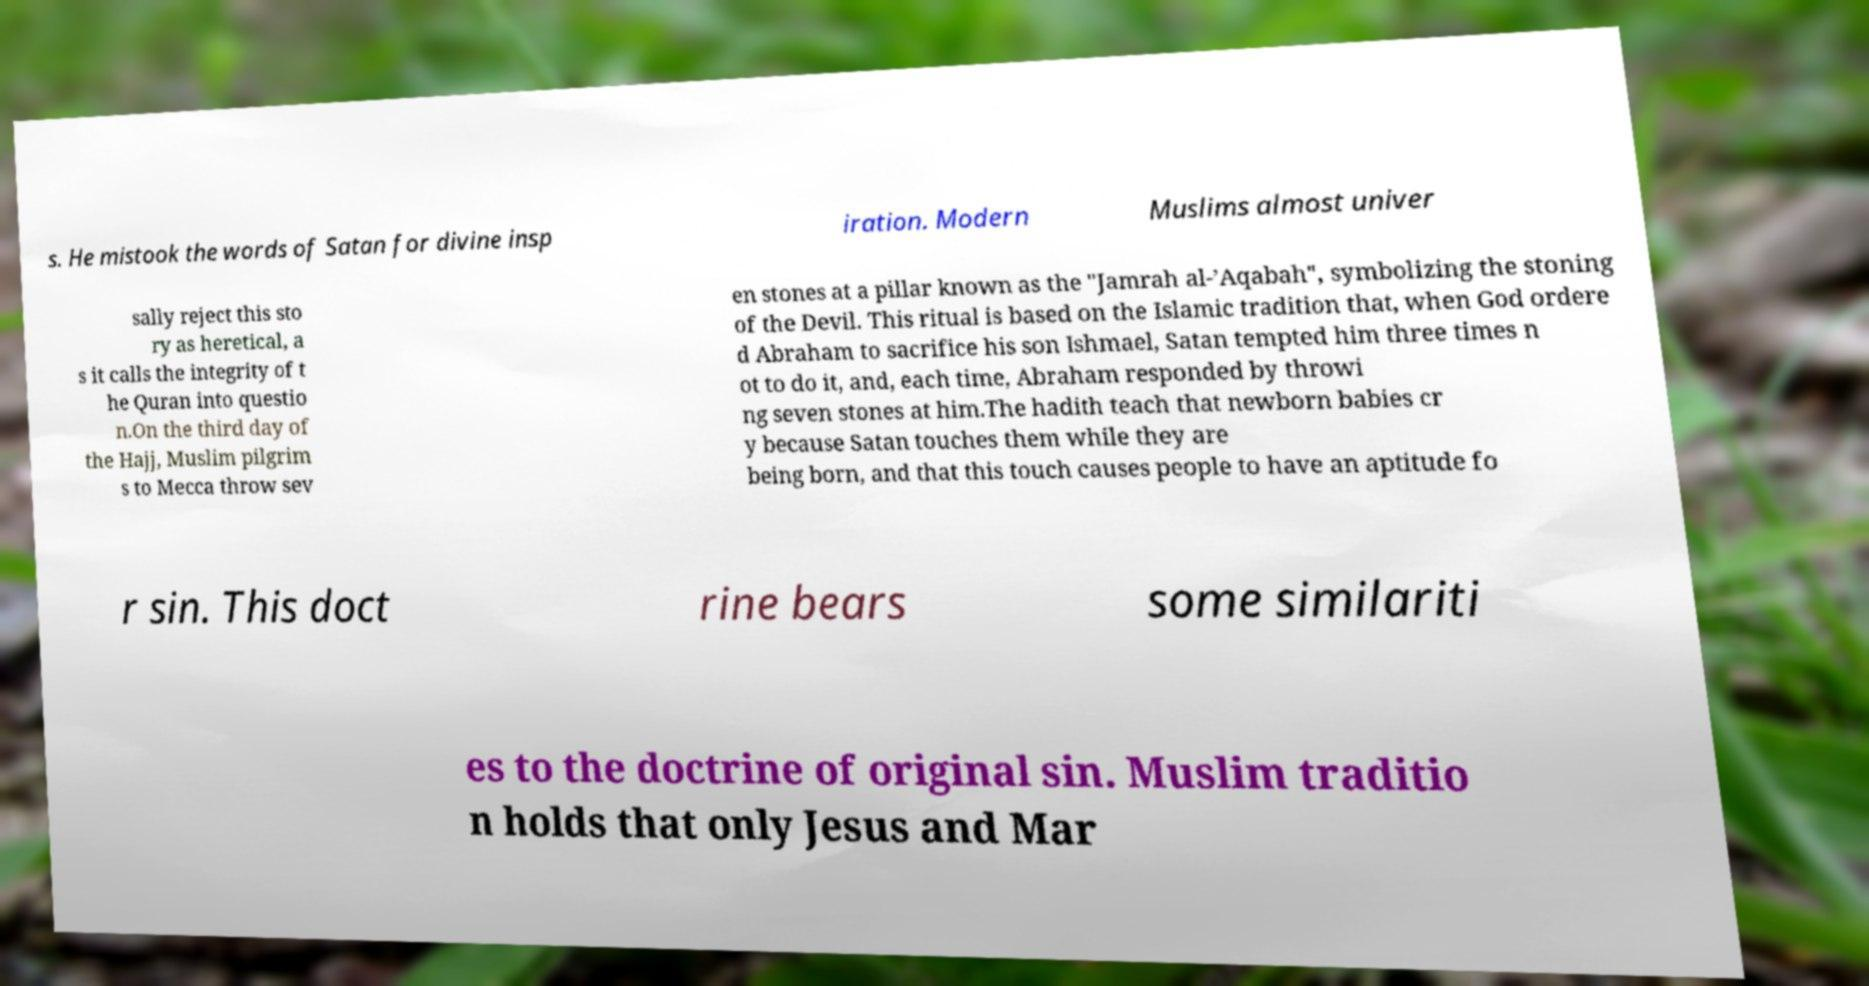Could you assist in decoding the text presented in this image and type it out clearly? s. He mistook the words of Satan for divine insp iration. Modern Muslims almost univer sally reject this sto ry as heretical, a s it calls the integrity of t he Quran into questio n.On the third day of the Hajj, Muslim pilgrim s to Mecca throw sev en stones at a pillar known as the "Jamrah al-’Aqabah", symbolizing the stoning of the Devil. This ritual is based on the Islamic tradition that, when God ordere d Abraham to sacrifice his son Ishmael, Satan tempted him three times n ot to do it, and, each time, Abraham responded by throwi ng seven stones at him.The hadith teach that newborn babies cr y because Satan touches them while they are being born, and that this touch causes people to have an aptitude fo r sin. This doct rine bears some similariti es to the doctrine of original sin. Muslim traditio n holds that only Jesus and Mar 